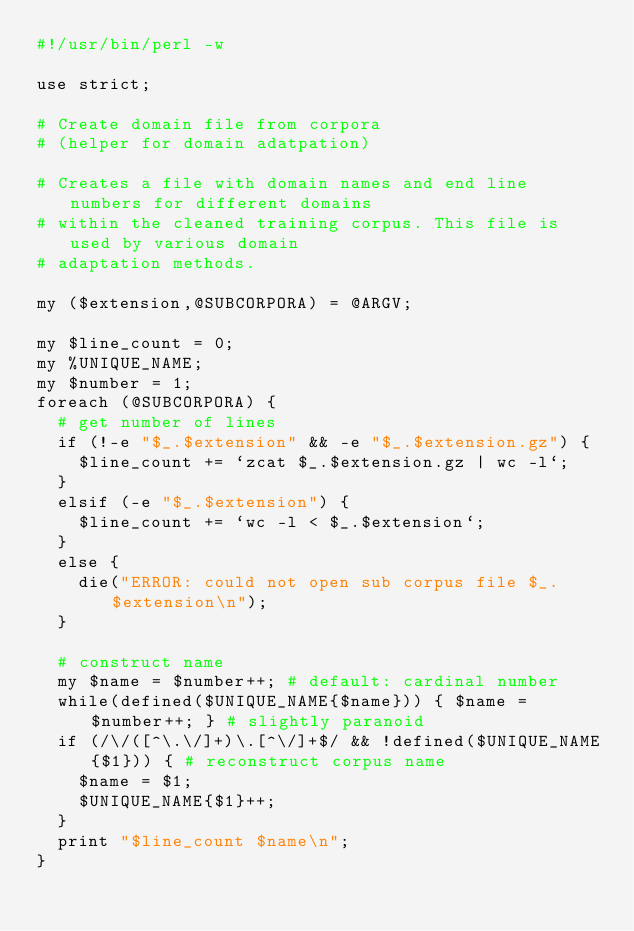Convert code to text. <code><loc_0><loc_0><loc_500><loc_500><_Perl_>#!/usr/bin/perl -w

use strict;

# Create domain file from corpora
# (helper for domain adatpation)

# Creates a file with domain names and end line numbers for different domains
# within the cleaned training corpus. This file is used by various domain 
# adaptation methods.

my ($extension,@SUBCORPORA) = @ARGV;

my $line_count = 0;
my %UNIQUE_NAME;
my $number = 1;
foreach (@SUBCORPORA) {
  # get number of lines
  if (!-e "$_.$extension" && -e "$_.$extension.gz") {
    $line_count += `zcat $_.$extension.gz | wc -l`;
  }
  elsif (-e "$_.$extension") {
    $line_count += `wc -l < $_.$extension`;
  }
  else {
    die("ERROR: could not open sub corpus file $_.$extension\n");
  }

  # construct name
  my $name = $number++; # default: cardinal number
  while(defined($UNIQUE_NAME{$name})) { $name = $number++; } # slightly paranoid
  if (/\/([^\.\/]+)\.[^\/]+$/ && !defined($UNIQUE_NAME{$1})) { # reconstruct corpus name
    $name = $1;
    $UNIQUE_NAME{$1}++;
  }
  print "$line_count $name\n";
}

</code> 